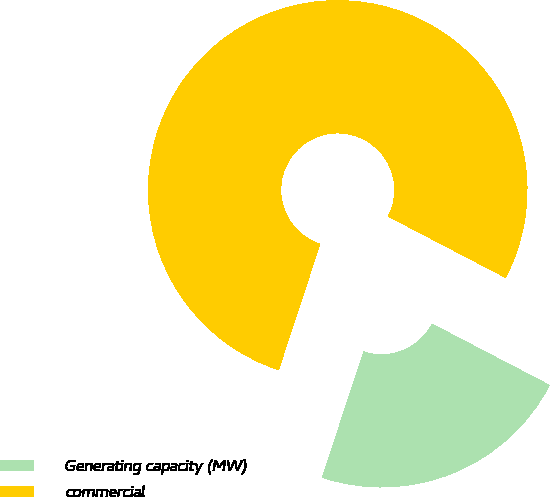Convert chart. <chart><loc_0><loc_0><loc_500><loc_500><pie_chart><fcel>Generating capacity (MW)<fcel>commercial<nl><fcel>22.41%<fcel>77.59%<nl></chart> 